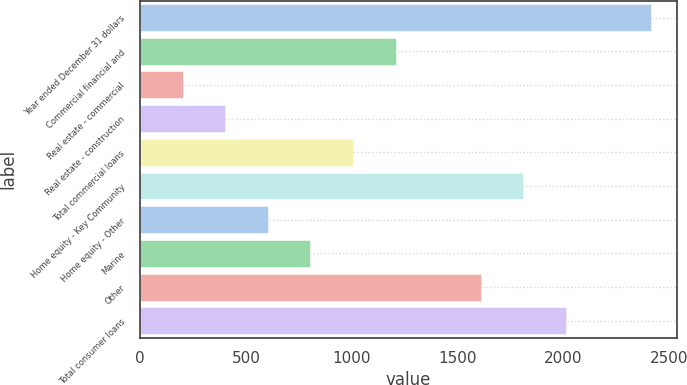Convert chart to OTSL. <chart><loc_0><loc_0><loc_500><loc_500><bar_chart><fcel>Year ended December 31 dollars<fcel>Commercial financial and<fcel>Real estate - commercial<fcel>Real estate - construction<fcel>Total commercial loans<fcel>Home equity - Key Community<fcel>Home equity - Other<fcel>Marine<fcel>Other<fcel>Total consumer loans<nl><fcel>2415.56<fcel>1207.94<fcel>201.59<fcel>402.86<fcel>1006.67<fcel>1811.75<fcel>604.13<fcel>805.4<fcel>1610.48<fcel>2013.02<nl></chart> 